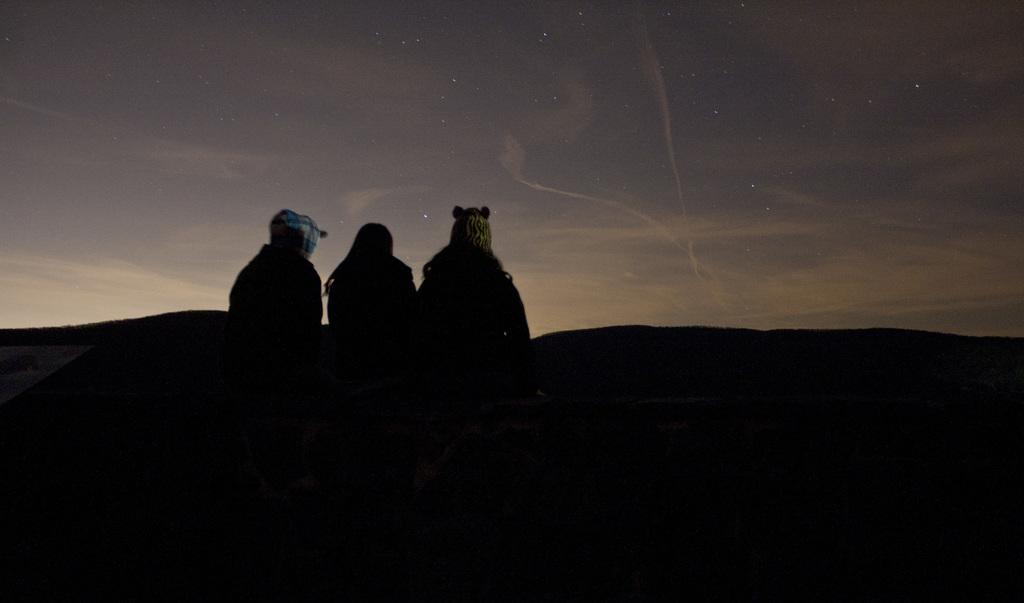How many people are sitting in the image? There are three persons sitting in the image. What is visible in the background of the image? There is sky visible in the image. Can you describe the sky in the image? The sky has clouds and stars in it. What type of creature is guiding the persons in the image? There is no creature present in the image, and the persons are not being guided by anyone or anything. 